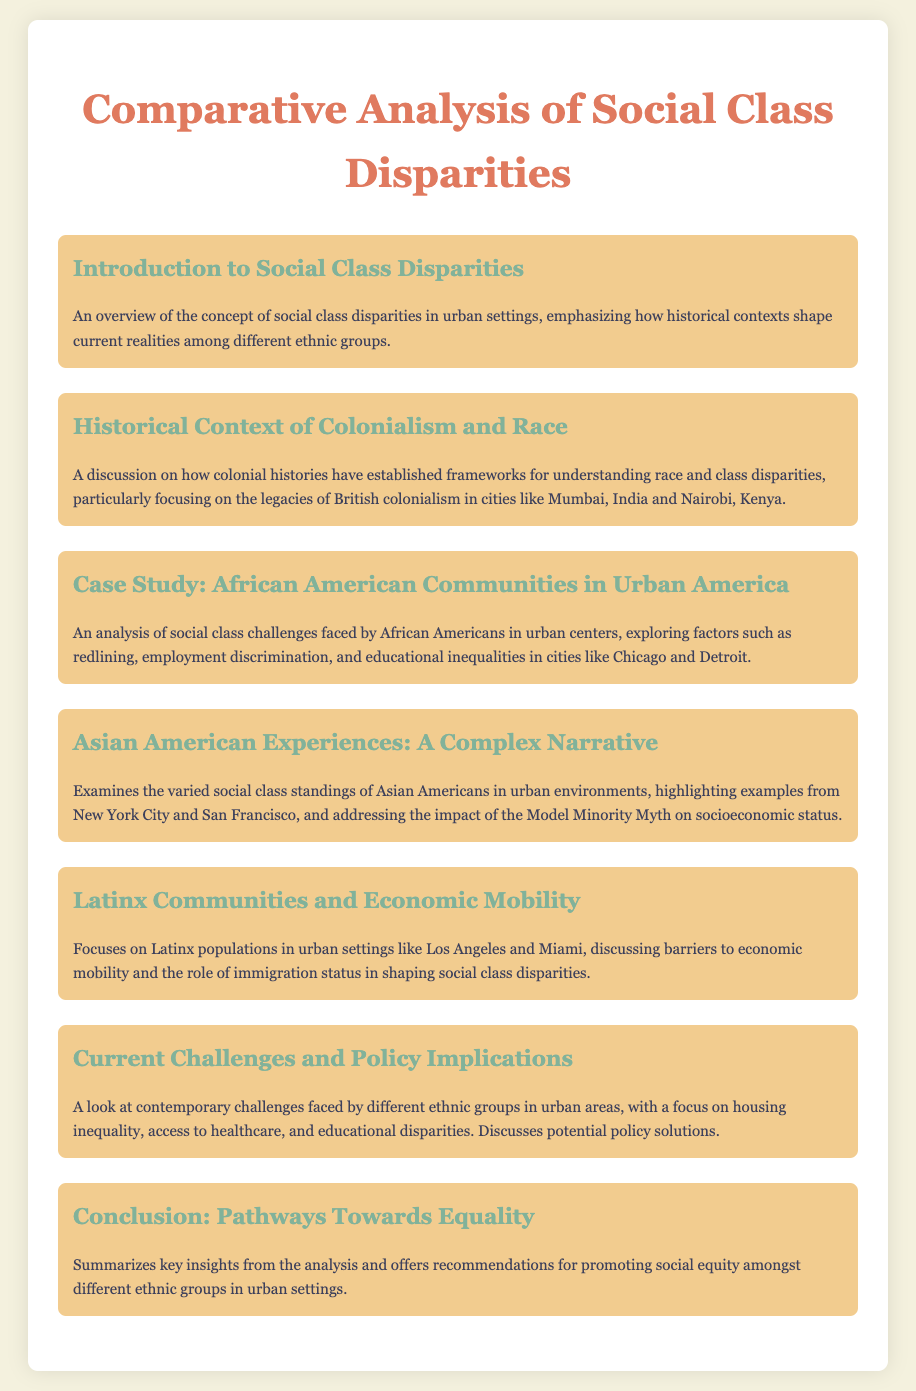What is the title of the document? The title is stated at the top of the document, presented in a large font.
Answer: Comparative Analysis of Social Class Disparities What ethnic group is focused on in the case study? The case study section specifically mentions African American communities.
Answer: African American Which urban area is highlighted for Latinx communities? The document mentions Los Angeles and Miami regarding Latinx populations.
Answer: Los Angeles and Miami What historical aspect affects current social class disparities? The document specifies colonial histories as a significant historical context.
Answer: Colonial histories What is discussed in the section about Asian American experiences? The document explains the Model Minority Myth and its impact on socioeconomic status.
Answer: Model Minority Myth How many sections are included in the document? The document contains several menu items, which are all sections in total.
Answer: Seven What is the final section titled? The last section summarizes the insights from the analysis and offers recommendations.
Answer: Conclusion: Pathways Towards Equality 